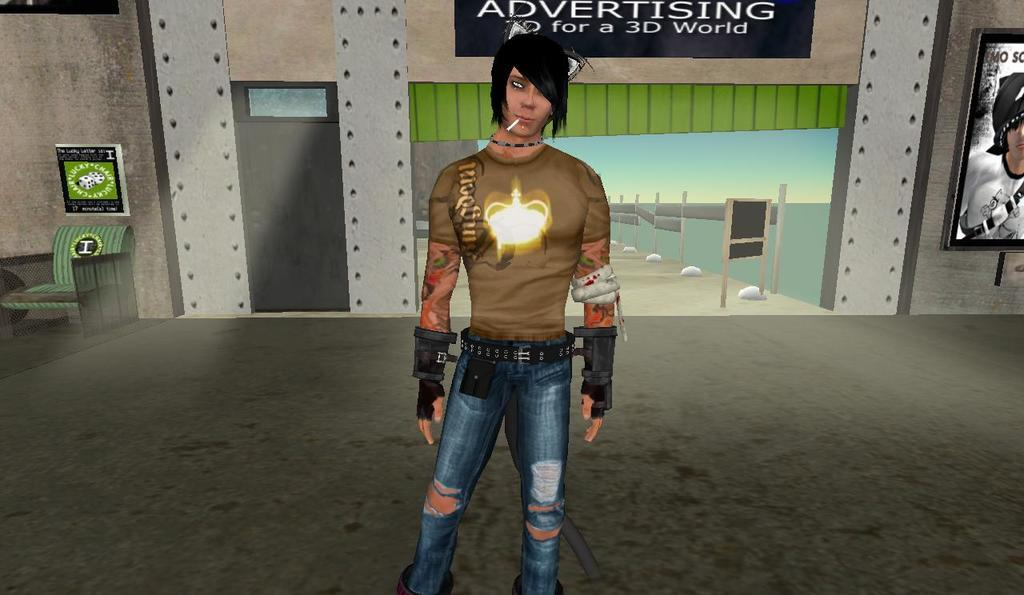What type of image is present in the picture? There is an animated image of a man in the picture. What architectural feature can be seen in the image? There is a door in the image. What is attached to the wall in the image? There is a wall with photos and other objects attached to it in the image. What type of furniture is present in the image? There is a chair in the image. What type of marble is used to decorate the floor in the image? There is no marble present in the image; it is an animated image with no floor visible. 